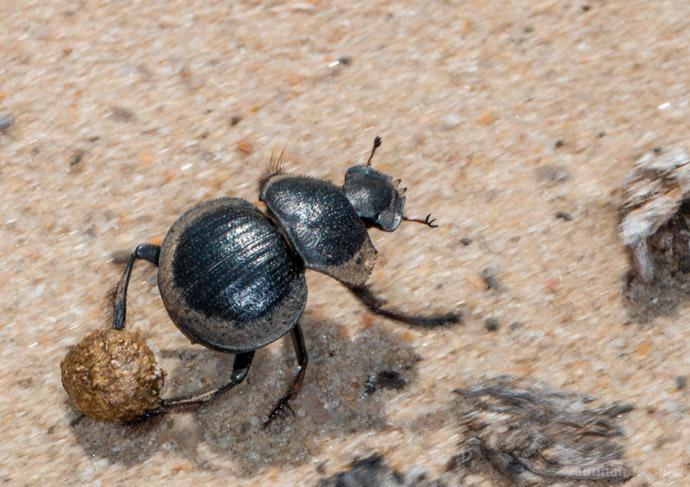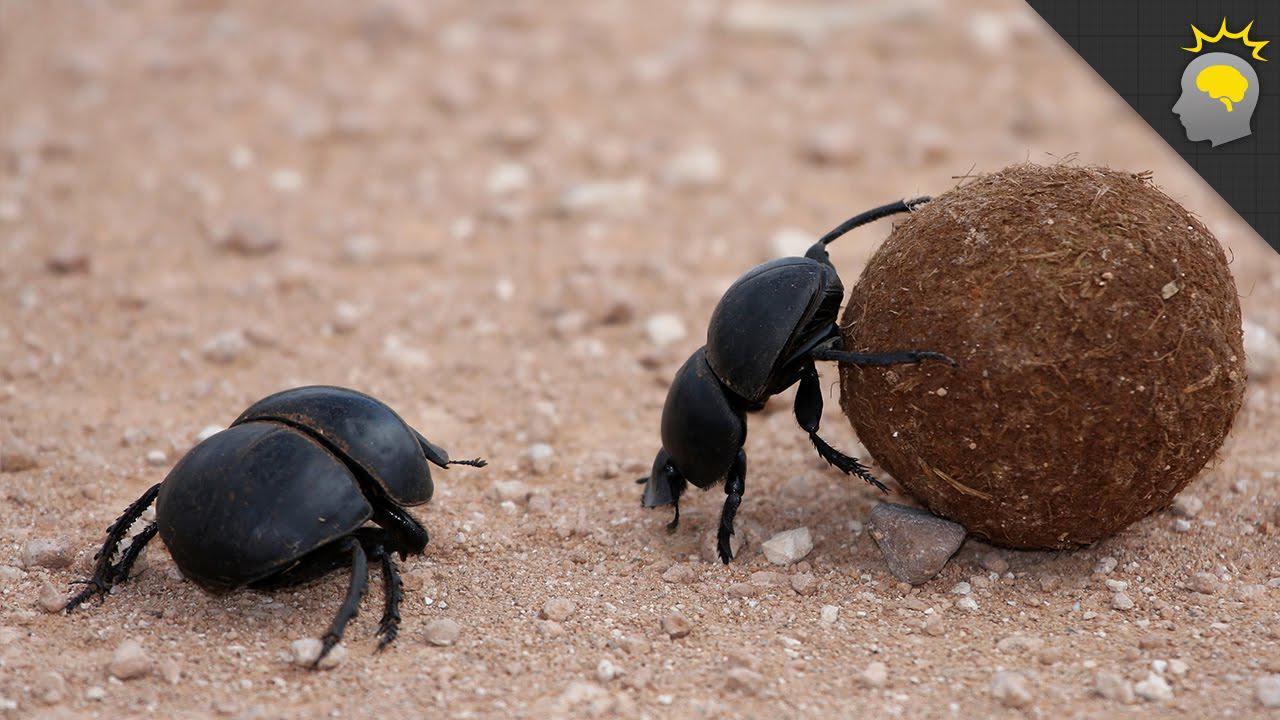The first image is the image on the left, the second image is the image on the right. Examine the images to the left and right. Is the description "An image of a beetle includes a thumb and fingers." accurate? Answer yes or no. No. The first image is the image on the left, the second image is the image on the right. Considering the images on both sides, is "The right image contains a human hand interacting with a dung beetle." valid? Answer yes or no. No. 